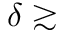<formula> <loc_0><loc_0><loc_500><loc_500>\delta \gtrsim</formula> 